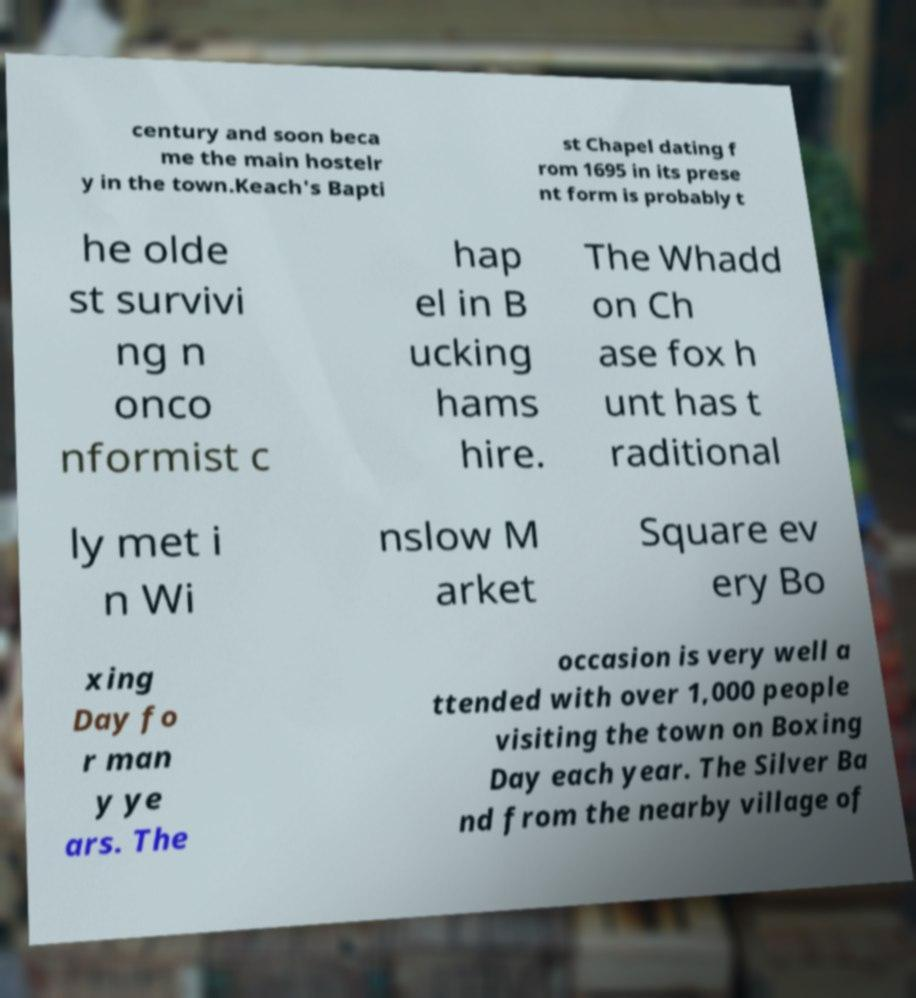Could you assist in decoding the text presented in this image and type it out clearly? century and soon beca me the main hostelr y in the town.Keach's Bapti st Chapel dating f rom 1695 in its prese nt form is probably t he olde st survivi ng n onco nformist c hap el in B ucking hams hire. The Whadd on Ch ase fox h unt has t raditional ly met i n Wi nslow M arket Square ev ery Bo xing Day fo r man y ye ars. The occasion is very well a ttended with over 1,000 people visiting the town on Boxing Day each year. The Silver Ba nd from the nearby village of 